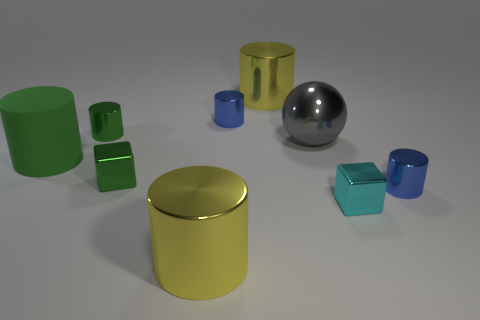Subtract all large shiny cylinders. How many cylinders are left? 4 Subtract all yellow cylinders. How many cylinders are left? 4 Subtract all brown cylinders. Subtract all cyan balls. How many cylinders are left? 6 Add 1 small cyan shiny objects. How many objects exist? 10 Subtract all cylinders. How many objects are left? 3 Subtract all green objects. Subtract all large green cylinders. How many objects are left? 5 Add 6 small cyan metal cubes. How many small cyan metal cubes are left? 7 Add 8 large cyan metallic blocks. How many large cyan metallic blocks exist? 8 Subtract 1 blue cylinders. How many objects are left? 8 